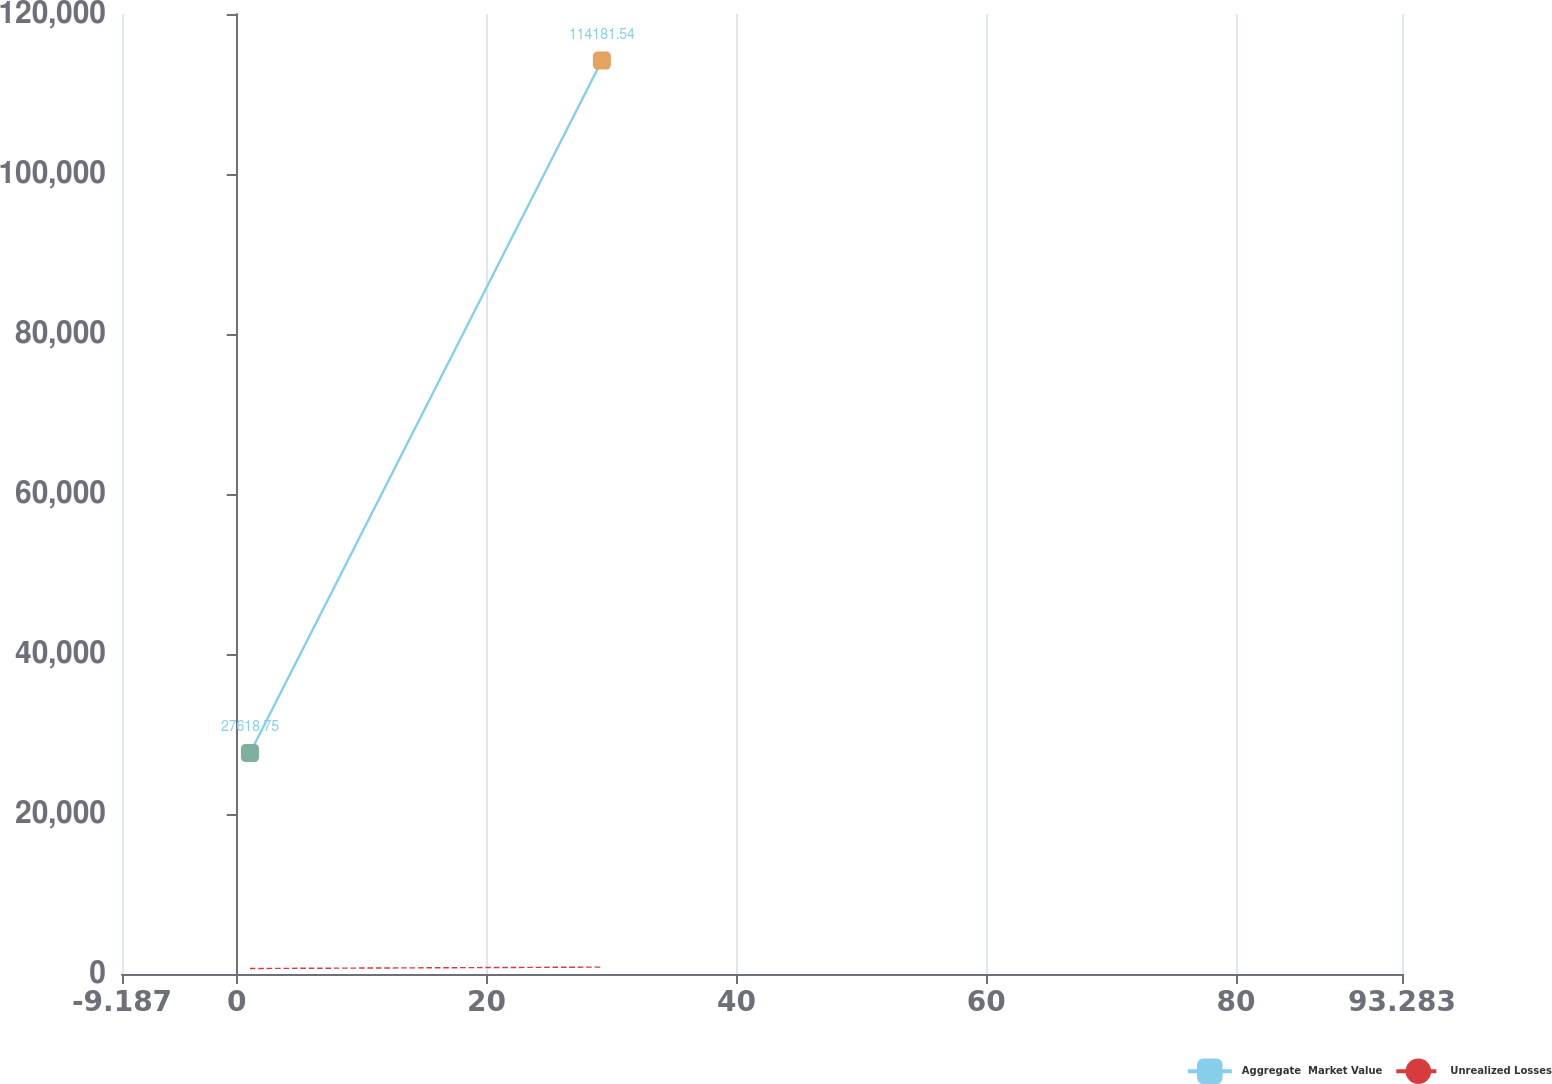Convert chart. <chart><loc_0><loc_0><loc_500><loc_500><line_chart><ecel><fcel>Aggregate  Market Value<fcel>Unrealized Losses<nl><fcel>1.06<fcel>27618.8<fcel>685.86<nl><fcel>29.23<fcel>114182<fcel>863.35<nl><fcel>93.63<fcel>2318.3<fcel>20.55<nl><fcel>103.53<fcel>176482<fcel>1795.41<nl></chart> 